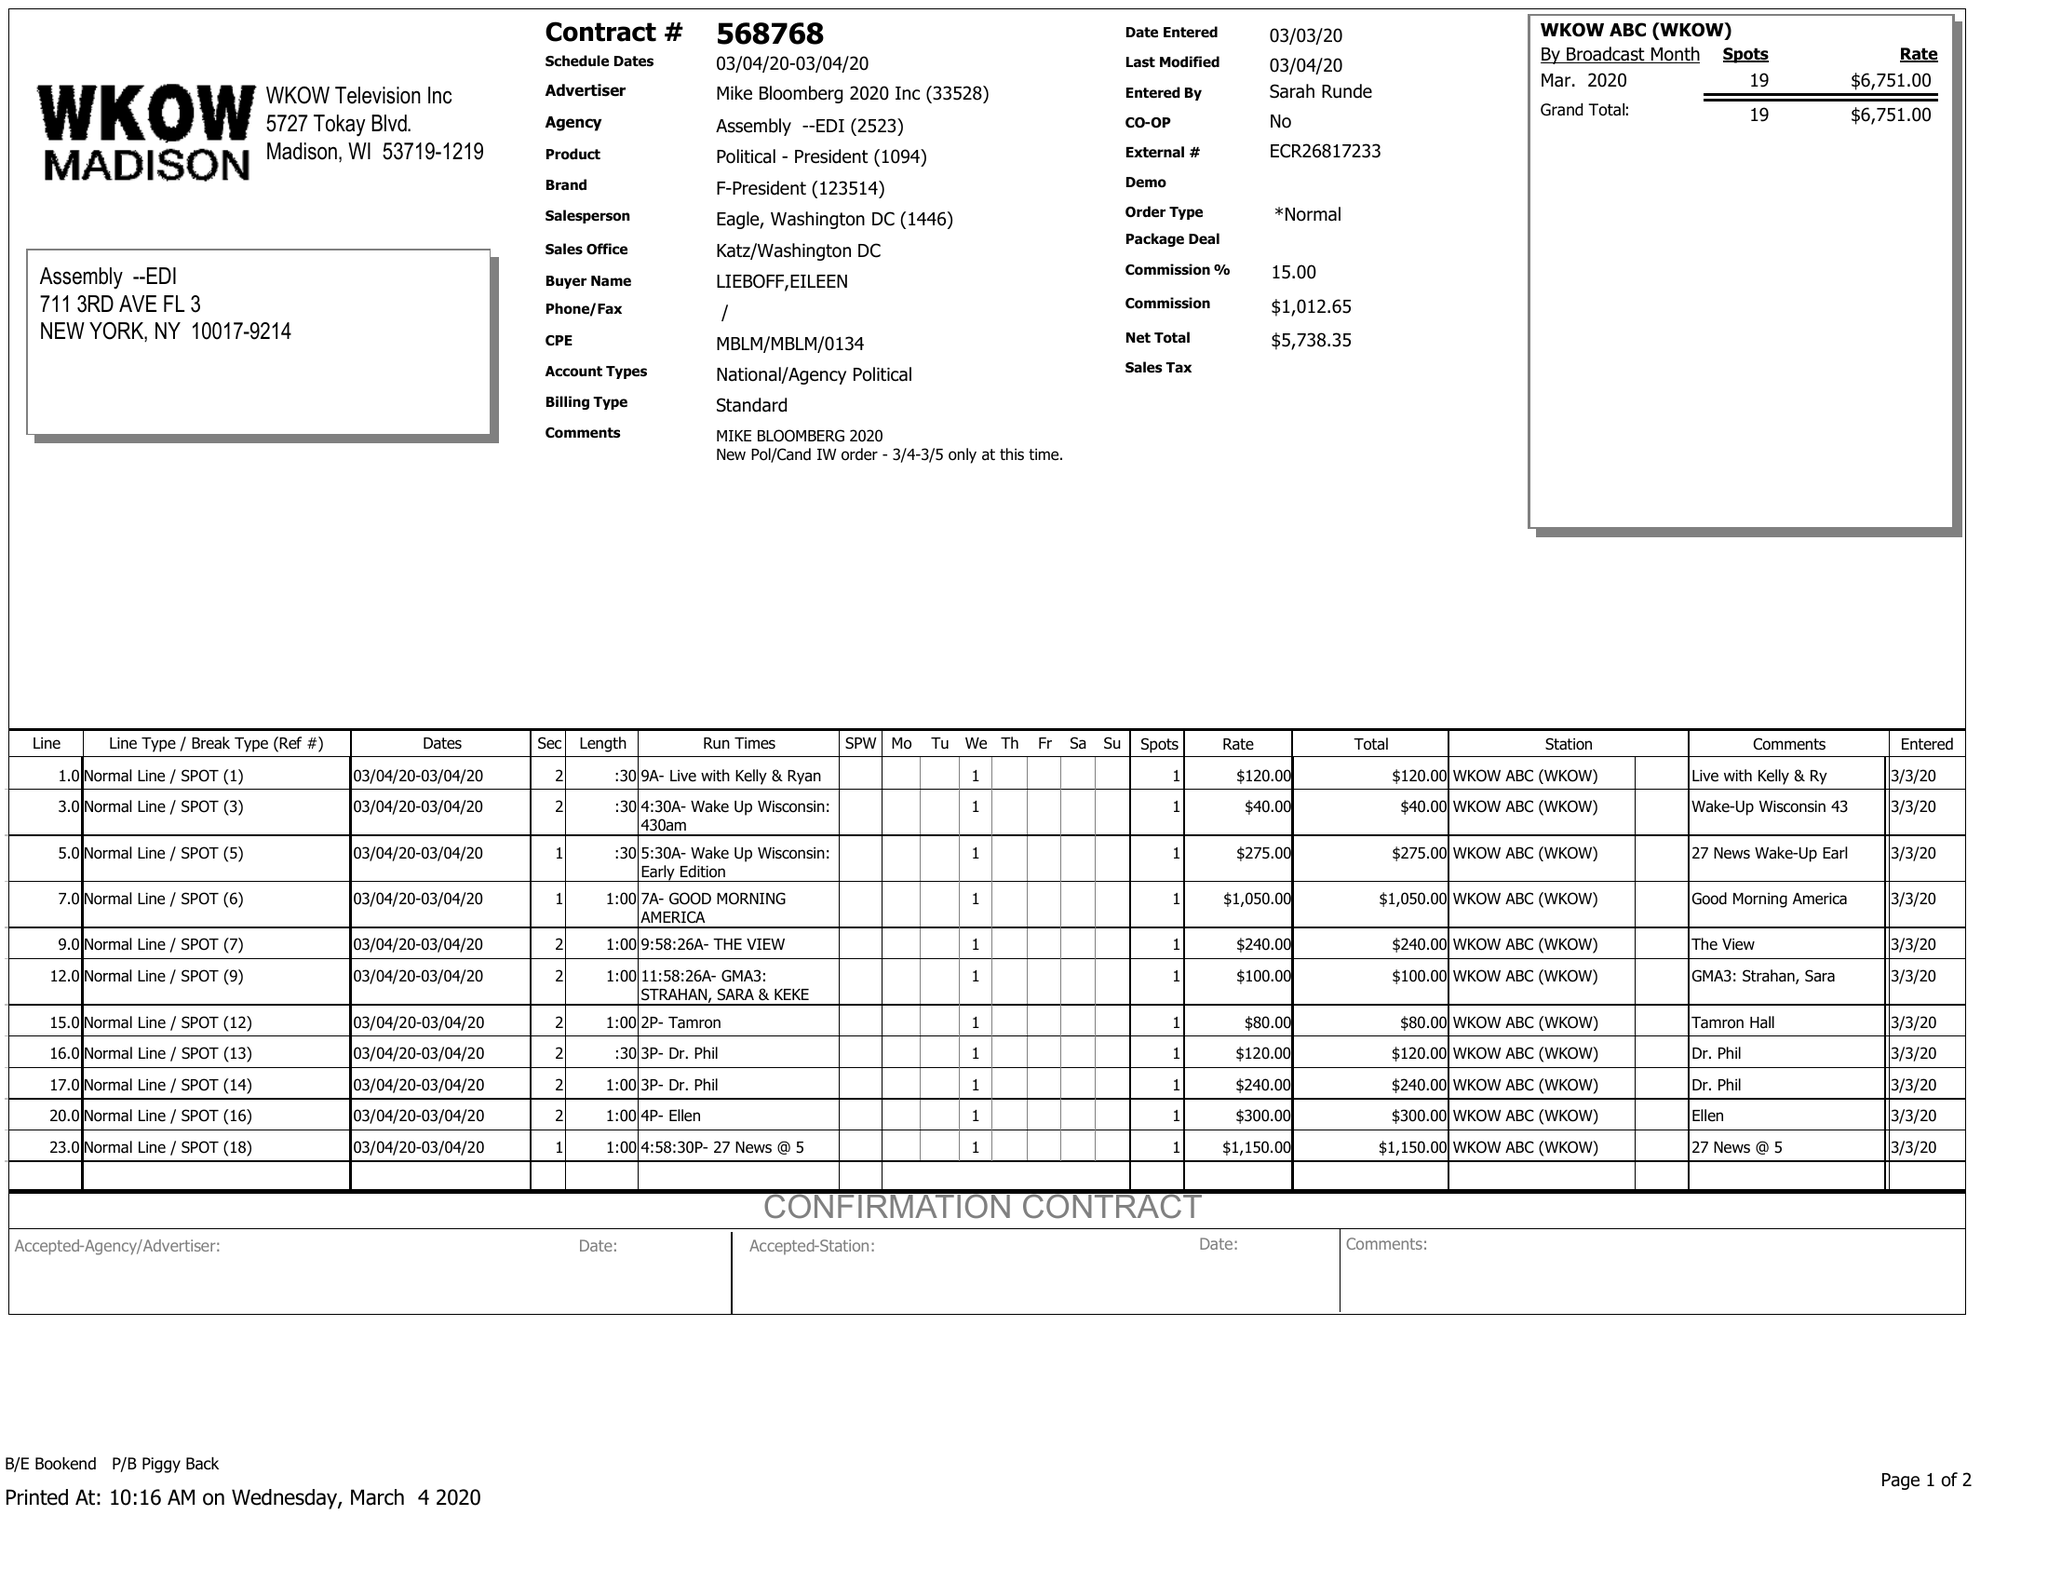What is the value for the flight_to?
Answer the question using a single word or phrase. 03/04/20 